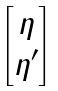Convert formula to latex. <formula><loc_0><loc_0><loc_500><loc_500>\begin{bmatrix} \eta \\ \eta ^ { \prime } \end{bmatrix}</formula> 